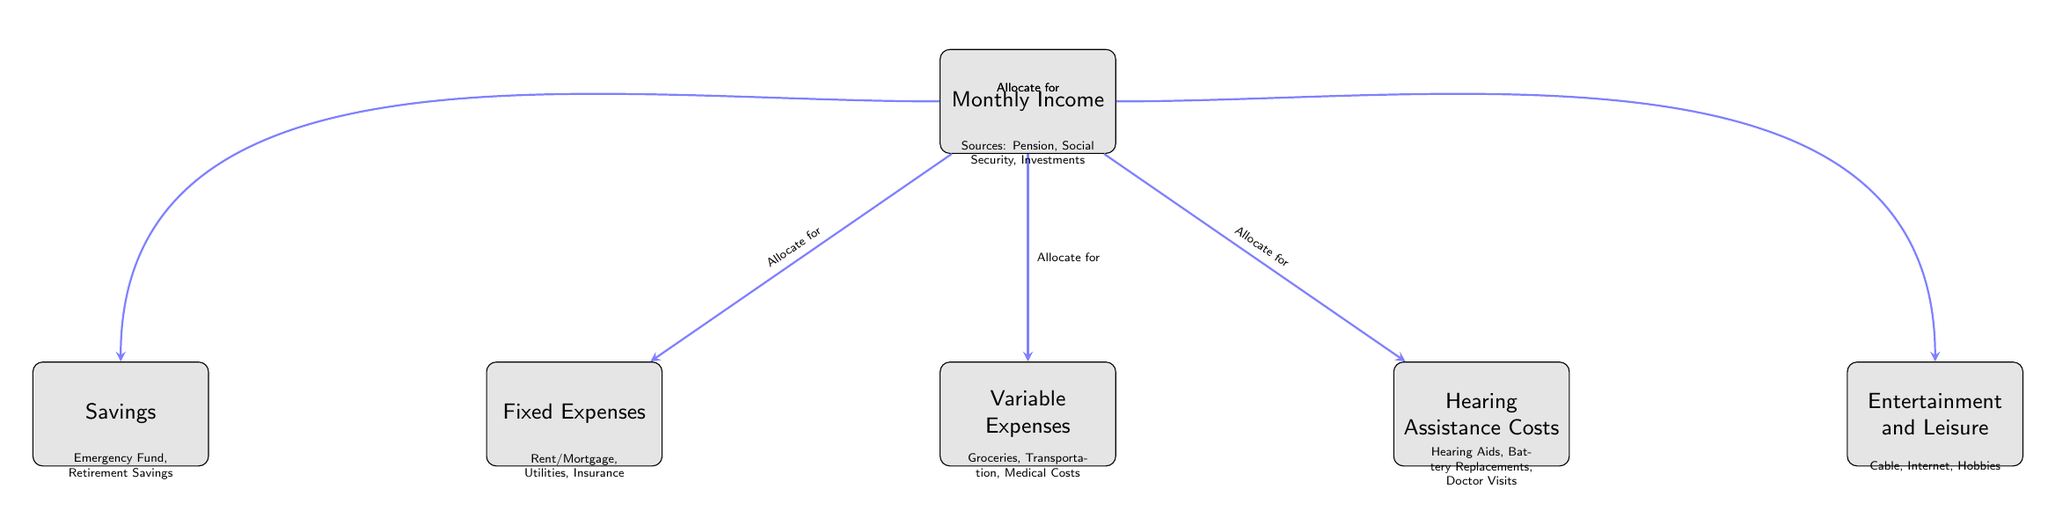What is the starting point of the flow chart? The flow chart begins with the node labeled "Monthly Income". This is the first node (id "1") from which all other allocations are made.
Answer: Monthly Income How many nodes are present in the diagram? The diagram contains six nodes, which are "Monthly Income", "Fixed Expenses", "Variable Expenses", "Hearing Assistance Costs", "Savings", and "Entertainment and Leisure". Counting each of these gives us a total.
Answer: 6 What type of expenses are categorized under node two? Node two is labeled "Fixed Expenses", which includes categories like Rent/Mortgage, Utilities, and Insurance. Therefore, the detailed costs in this node pertain to fixed expenses.
Answer: Fixed Expenses Which category involves costs related to hearing aids? The category involving costs related to hearing aids is found under the node labeled "Hearing Assistance Costs", which specifies items like Hearing Aids, Battery Replacements, and Doctor Visits.
Answer: Hearing Assistance Costs What is the relationship between "Monthly Income" and "Savings"? The diagram shows that the "Monthly Income" node leads to the "Savings" node with the label "Allocate for Savings", indicating that a portion of the monthly income is designated for savings.
Answer: Allocate for Savings How are variable expenses allocated from monthly income? The allocation for variable expenses is indicated by the connection from "Monthly Income" to "Variable Expenses", labeled "Allocate for Variable Expenses", meaning a portion of income is used for variable costs.
Answer: Allocate for Variable Expenses What does the "Entertainment and Leisure" category include? The "Entertainment and Leisure" category includes costs such as Cable, Internet, and Hobbies, as detailed under node six.
Answer: Cable, Internet, Hobbies If fixed expenses and savings are covered, what other allocations can be made from monthly income? After deducting fixed expenses and savings, monthly income can still be allocated to "Variable Expenses", "Hearing Assistance Costs", and "Entertainment and Leisure", as indicated by their connections to the "Monthly Income" node.
Answer: Variable Expenses, Hearing Assistance Costs, Entertainment and Leisure What connects all categories in the flow chart? All categories are connected to the "Monthly Income" node as allocations are made from it to other nodes, establishing that all expenses and savings depend on the total monthly income allocated at the beginning.
Answer: Monthly Income 